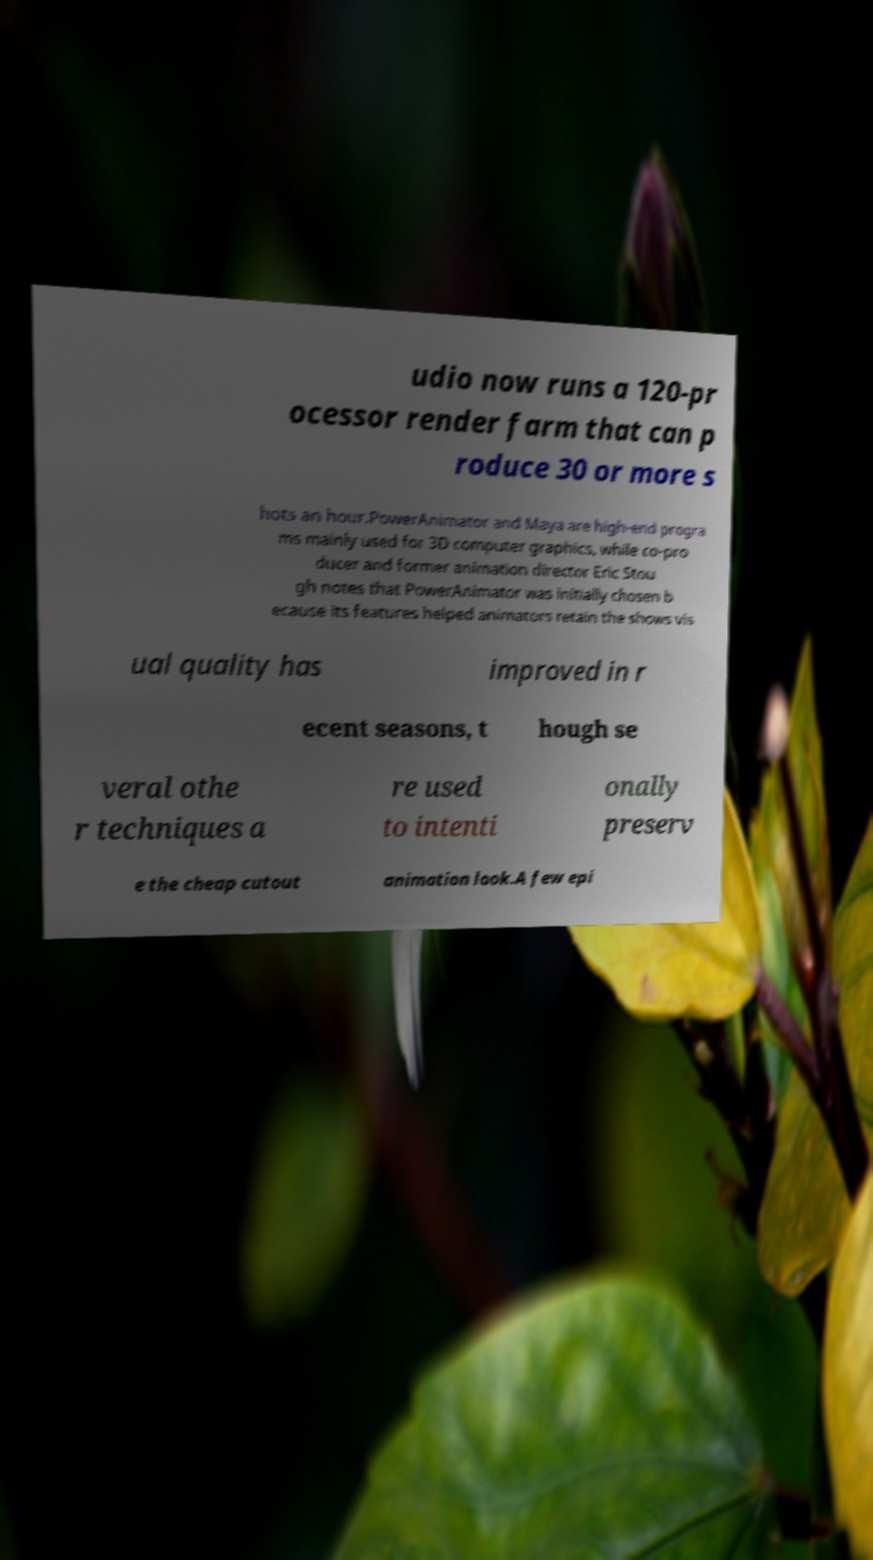What messages or text are displayed in this image? I need them in a readable, typed format. udio now runs a 120-pr ocessor render farm that can p roduce 30 or more s hots an hour.PowerAnimator and Maya are high-end progra ms mainly used for 3D computer graphics, while co-pro ducer and former animation director Eric Stou gh notes that PowerAnimator was initially chosen b ecause its features helped animators retain the shows vis ual quality has improved in r ecent seasons, t hough se veral othe r techniques a re used to intenti onally preserv e the cheap cutout animation look.A few epi 